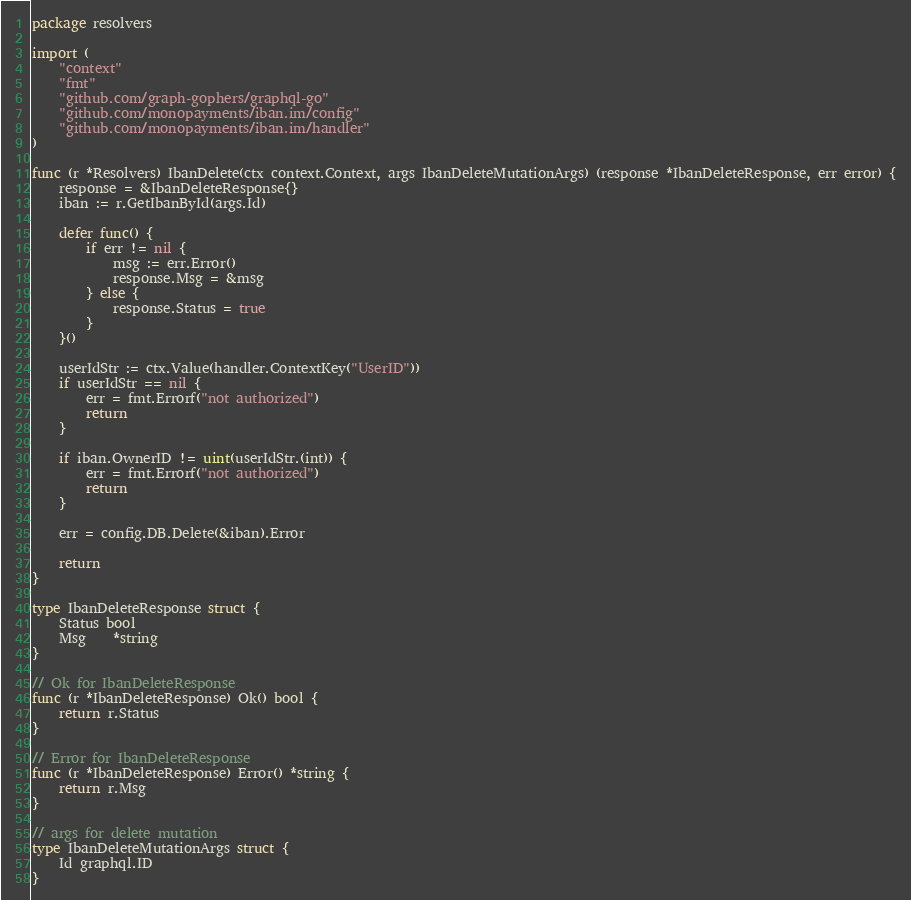Convert code to text. <code><loc_0><loc_0><loc_500><loc_500><_Go_>package resolvers

import (
	"context"
	"fmt"
	"github.com/graph-gophers/graphql-go"
	"github.com/monopayments/iban.im/config"
	"github.com/monopayments/iban.im/handler"
)

func (r *Resolvers) IbanDelete(ctx context.Context, args IbanDeleteMutationArgs) (response *IbanDeleteResponse, err error) {
	response = &IbanDeleteResponse{}
	iban := r.GetIbanById(args.Id)

	defer func() {
		if err != nil {
			msg := err.Error()
			response.Msg = &msg
		} else {
			response.Status = true
		}
	}()

	userIdStr := ctx.Value(handler.ContextKey("UserID"))
	if userIdStr == nil {
		err = fmt.Errorf("not authorized")
		return
	}

	if iban.OwnerID != uint(userIdStr.(int)) {
		err = fmt.Errorf("not authorized")
		return
	}

	err = config.DB.Delete(&iban).Error

	return
}

type IbanDeleteResponse struct {
	Status bool
	Msg    *string
}

// Ok for IbanDeleteResponse
func (r *IbanDeleteResponse) Ok() bool {
	return r.Status
}

// Error for IbanDeleteResponse
func (r *IbanDeleteResponse) Error() *string {
	return r.Msg
}

// args for delete mutation
type IbanDeleteMutationArgs struct {
	Id graphql.ID
}
</code> 